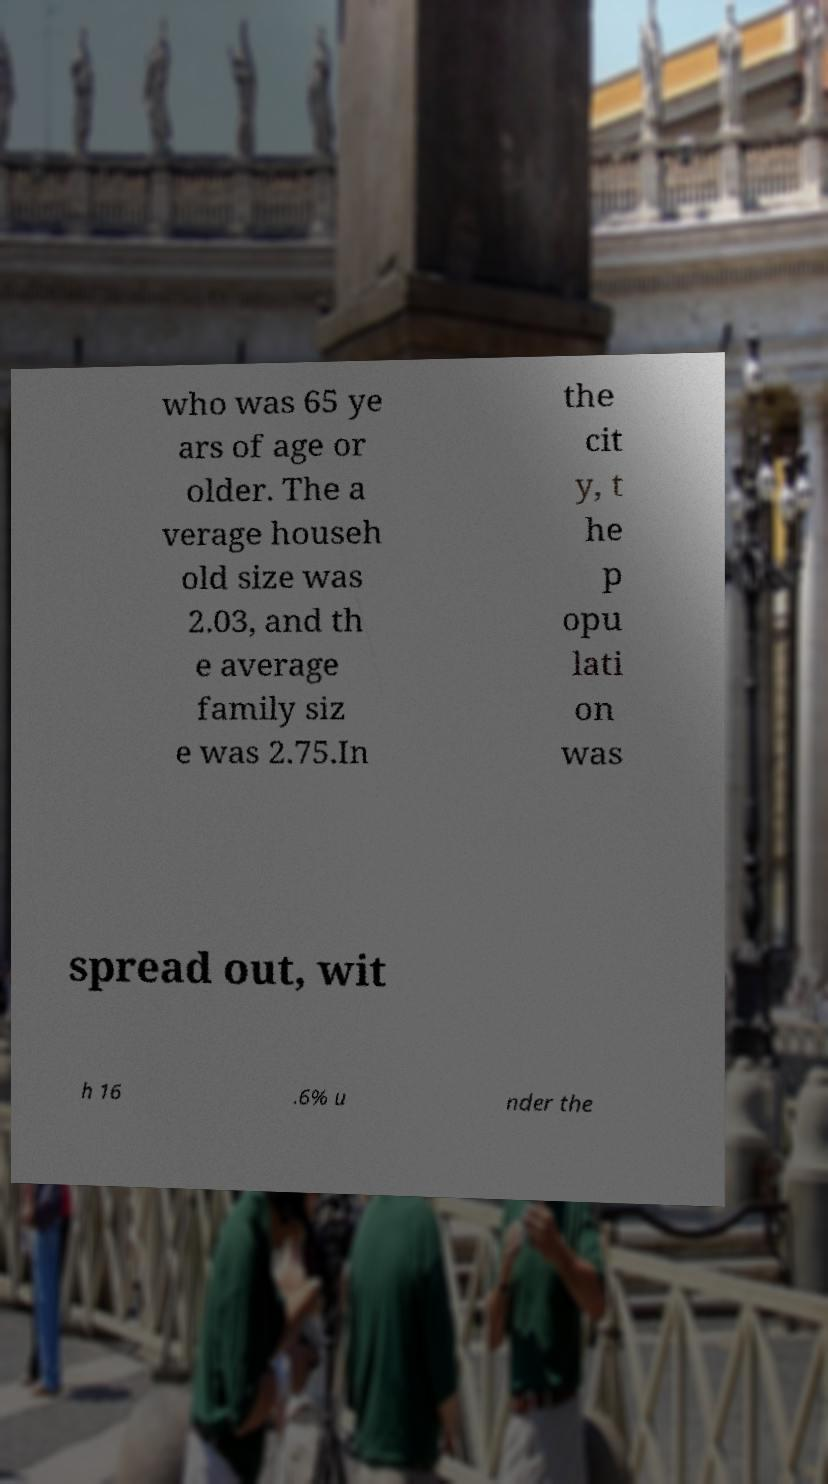Please identify and transcribe the text found in this image. who was 65 ye ars of age or older. The a verage househ old size was 2.03, and th e average family siz e was 2.75.In the cit y, t he p opu lati on was spread out, wit h 16 .6% u nder the 